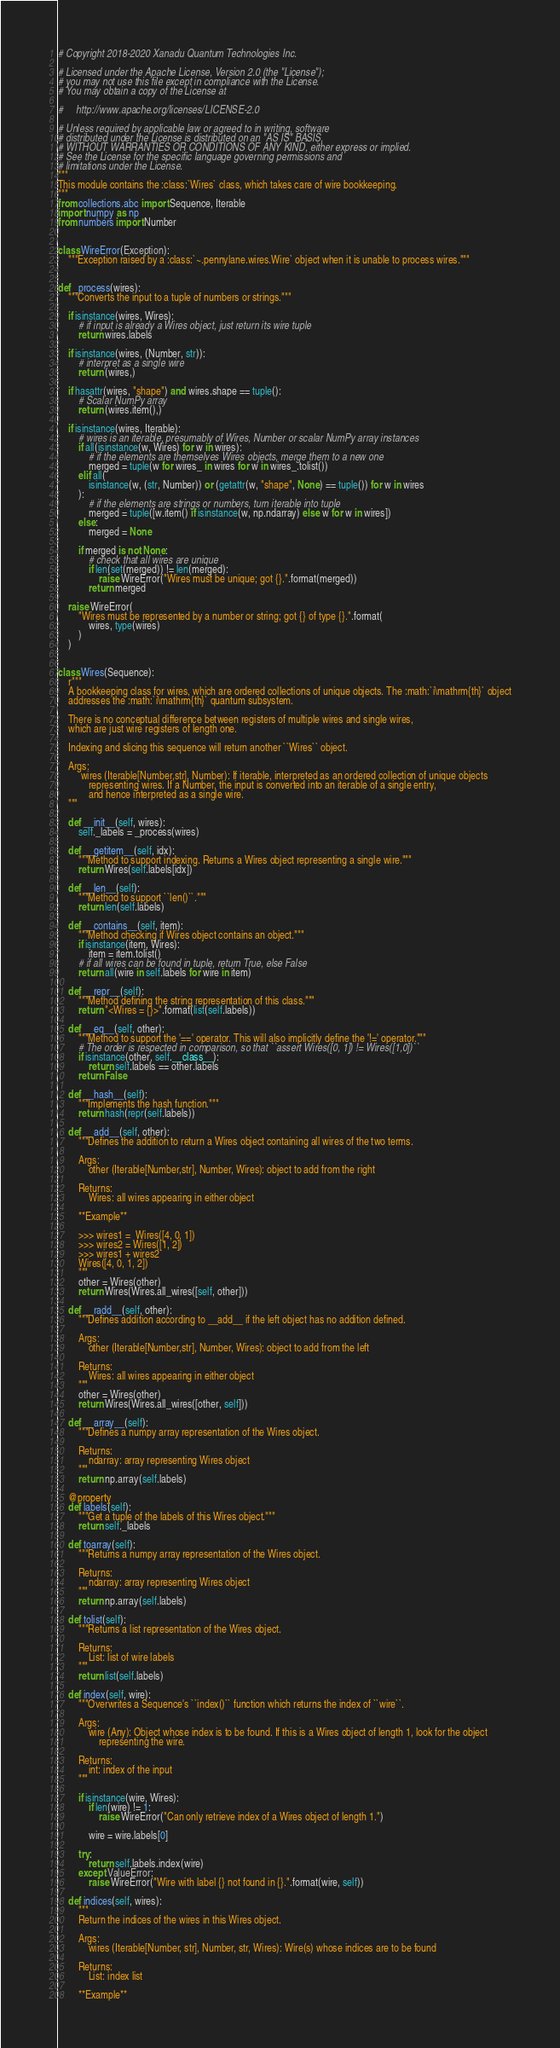<code> <loc_0><loc_0><loc_500><loc_500><_Python_># Copyright 2018-2020 Xanadu Quantum Technologies Inc.

# Licensed under the Apache License, Version 2.0 (the "License");
# you may not use this file except in compliance with the License.
# You may obtain a copy of the License at

#     http://www.apache.org/licenses/LICENSE-2.0

# Unless required by applicable law or agreed to in writing, software
# distributed under the License is distributed on an "AS IS" BASIS,
# WITHOUT WARRANTIES OR CONDITIONS OF ANY KIND, either express or implied.
# See the License for the specific language governing permissions and
# limitations under the License.
"""
This module contains the :class:`Wires` class, which takes care of wire bookkeeping.
"""
from collections.abc import Sequence, Iterable
import numpy as np
from numbers import Number


class WireError(Exception):
    """Exception raised by a :class:`~.pennylane.wires.Wire` object when it is unable to process wires."""


def _process(wires):
    """Converts the input to a tuple of numbers or strings."""

    if isinstance(wires, Wires):
        # if input is already a Wires object, just return its wire tuple
        return wires.labels

    if isinstance(wires, (Number, str)):
        # interpret as a single wire
        return (wires,)

    if hasattr(wires, "shape") and wires.shape == tuple():
        # Scalar NumPy array
        return (wires.item(),)

    if isinstance(wires, Iterable):
        # wires is an iterable, presumably of Wires, Number or scalar NumPy array instances
        if all(isinstance(w, Wires) for w in wires):
            # if the elements are themselves Wires objects, merge them to a new one
            merged = tuple(w for wires_ in wires for w in wires_.tolist())
        elif all(
            isinstance(w, (str, Number)) or (getattr(w, "shape", None) == tuple()) for w in wires
        ):
            # if the elements are strings or numbers, turn iterable into tuple
            merged = tuple([w.item() if isinstance(w, np.ndarray) else w for w in wires])
        else:
            merged = None

        if merged is not None:
            # check that all wires are unique
            if len(set(merged)) != len(merged):
                raise WireError("Wires must be unique; got {}.".format(merged))
            return merged

    raise WireError(
        "Wires must be represented by a number or string; got {} of type {}.".format(
            wires, type(wires)
        )
    )


class Wires(Sequence):
    r"""
    A bookkeeping class for wires, which are ordered collections of unique objects. The :math:`i\mathrm{th}` object
    addresses the :math:`i\mathrm{th}` quantum subsystem.

    There is no conceptual difference between registers of multiple wires and single wires,
    which are just wire registers of length one.

    Indexing and slicing this sequence will return another ``Wires`` object.

    Args:
         wires (Iterable[Number,str], Number): If iterable, interpreted as an ordered collection of unique objects
            representing wires. If a Number, the input is converted into an iterable of a single entry,
            and hence interpreted as a single wire.
    """

    def __init__(self, wires):
        self._labels = _process(wires)

    def __getitem__(self, idx):
        """Method to support indexing. Returns a Wires object representing a single wire."""
        return Wires(self.labels[idx])

    def __len__(self):
        """Method to support ``len()``."""
        return len(self.labels)

    def __contains__(self, item):
        """Method checking if Wires object contains an object."""
        if isinstance(item, Wires):
            item = item.tolist()
        # if all wires can be found in tuple, return True, else False
        return all(wire in self.labels for wire in item)

    def __repr__(self):
        """Method defining the string representation of this class."""
        return "<Wires = {}>".format(list(self.labels))

    def __eq__(self, other):
        """Method to support the '==' operator. This will also implicitly define the '!=' operator."""
        # The order is respected in comparison, so that ``assert Wires([0, 1]) != Wires([1,0])``
        if isinstance(other, self.__class__):
            return self.labels == other.labels
        return False

    def __hash__(self):
        """Implements the hash function."""
        return hash(repr(self.labels))

    def __add__(self, other):
        """Defines the addition to return a Wires object containing all wires of the two terms.

        Args:
            other (Iterable[Number,str], Number, Wires): object to add from the right

        Returns:
            Wires: all wires appearing in either object

        **Example**

        >>> wires1 =  Wires([4, 0, 1])
        >>> wires2 = Wires([1, 2])
        >>> wires1 + wires2
        Wires([4, 0, 1, 2])
        """
        other = Wires(other)
        return Wires(Wires.all_wires([self, other]))

    def __radd__(self, other):
        """Defines addition according to __add__ if the left object has no addition defined.

        Args:
            other (Iterable[Number,str], Number, Wires): object to add from the left

        Returns:
            Wires: all wires appearing in either object
        """
        other = Wires(other)
        return Wires(Wires.all_wires([other, self]))

    def __array__(self):
        """Defines a numpy array representation of the Wires object.

        Returns:
            ndarray: array representing Wires object
        """
        return np.array(self.labels)

    @property
    def labels(self):
        """Get a tuple of the labels of this Wires object."""
        return self._labels

    def toarray(self):
        """Returns a numpy array representation of the Wires object.

        Returns:
            ndarray: array representing Wires object
        """
        return np.array(self.labels)

    def tolist(self):
        """Returns a list representation of the Wires object.

        Returns:
            List: list of wire labels
        """
        return list(self.labels)

    def index(self, wire):
        """Overwrites a Sequence's ``index()`` function which returns the index of ``wire``.

        Args:
            wire (Any): Object whose index is to be found. If this is a Wires object of length 1, look for the object
                representing the wire.

        Returns:
            int: index of the input
        """

        if isinstance(wire, Wires):
            if len(wire) != 1:
                raise WireError("Can only retrieve index of a Wires object of length 1.")

            wire = wire.labels[0]

        try:
            return self.labels.index(wire)
        except ValueError:
            raise WireError("Wire with label {} not found in {}.".format(wire, self))

    def indices(self, wires):
        """
        Return the indices of the wires in this Wires object.

        Args:
            wires (Iterable[Number, str], Number, str, Wires): Wire(s) whose indices are to be found

        Returns:
            List: index list

        **Example**
</code> 